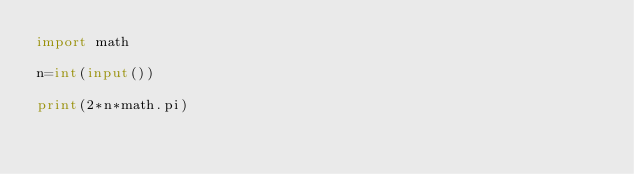<code> <loc_0><loc_0><loc_500><loc_500><_Python_>import math

n=int(input())

print(2*n*math.pi)</code> 